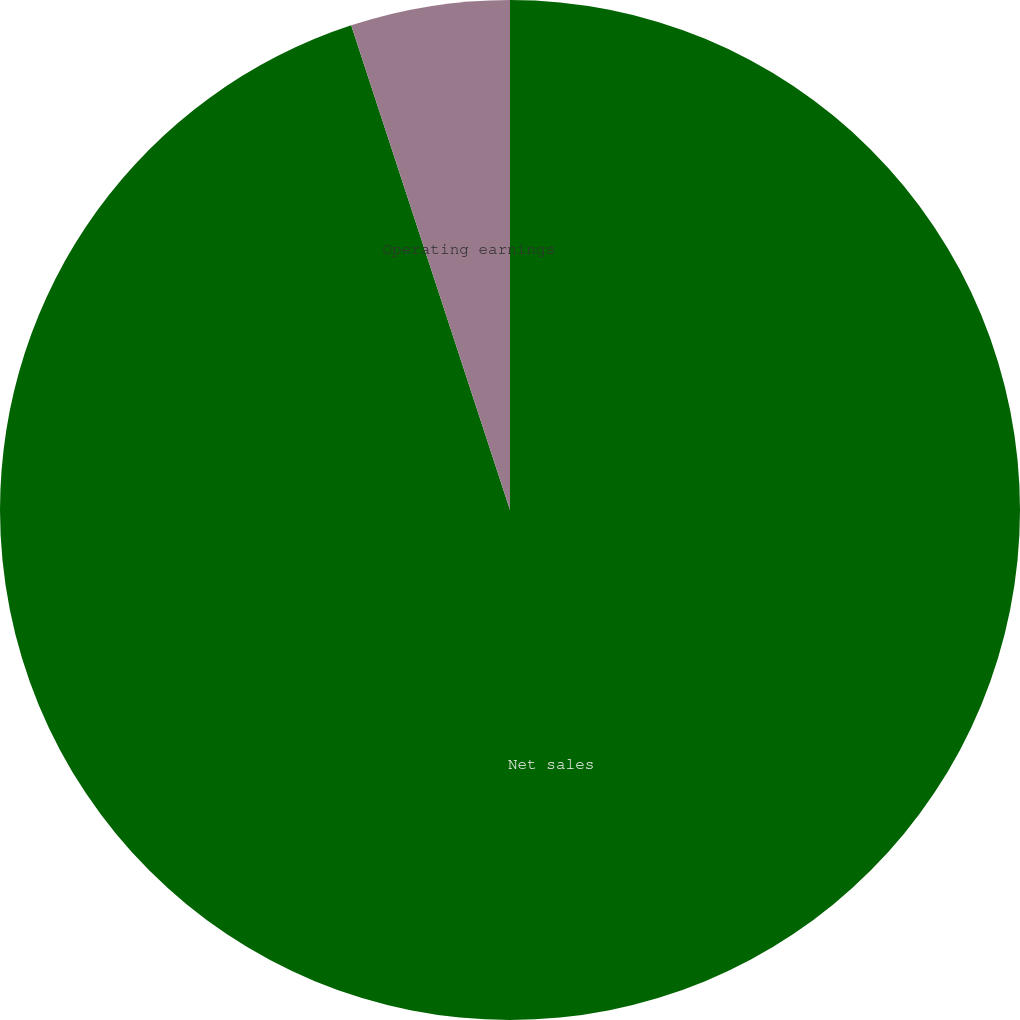<chart> <loc_0><loc_0><loc_500><loc_500><pie_chart><fcel>Net sales<fcel>Operating earnings<nl><fcel>94.96%<fcel>5.04%<nl></chart> 